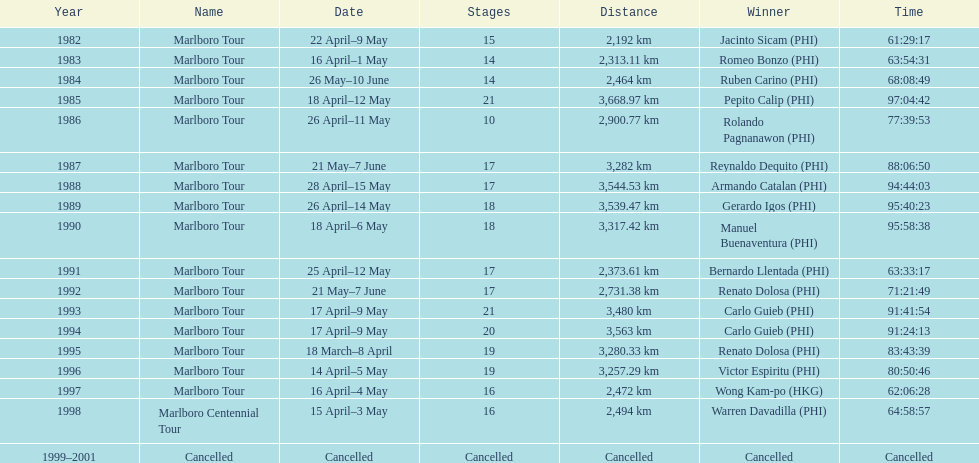What was the total number of winners before the tour was canceled? 17. 